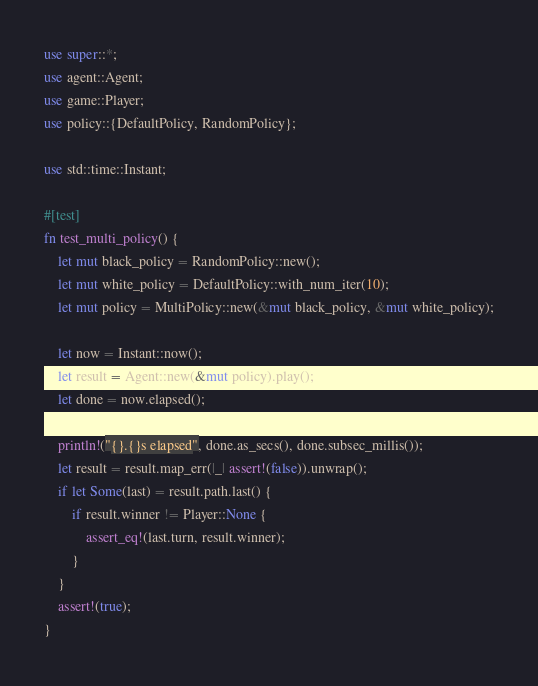<code> <loc_0><loc_0><loc_500><loc_500><_Rust_>use super::*;
use agent::Agent;
use game::Player;
use policy::{DefaultPolicy, RandomPolicy};

use std::time::Instant;

#[test]
fn test_multi_policy() {
    let mut black_policy = RandomPolicy::new();
    let mut white_policy = DefaultPolicy::with_num_iter(10);
    let mut policy = MultiPolicy::new(&mut black_policy, &mut white_policy);

    let now = Instant::now();
    let result = Agent::new(&mut policy).play();
    let done = now.elapsed();

    println!("{}.{}s elapsed", done.as_secs(), done.subsec_millis());
    let result = result.map_err(|_| assert!(false)).unwrap();
    if let Some(last) = result.path.last() {
        if result.winner != Player::None {
            assert_eq!(last.turn, result.winner);
        }
    }
    assert!(true);
}
</code> 